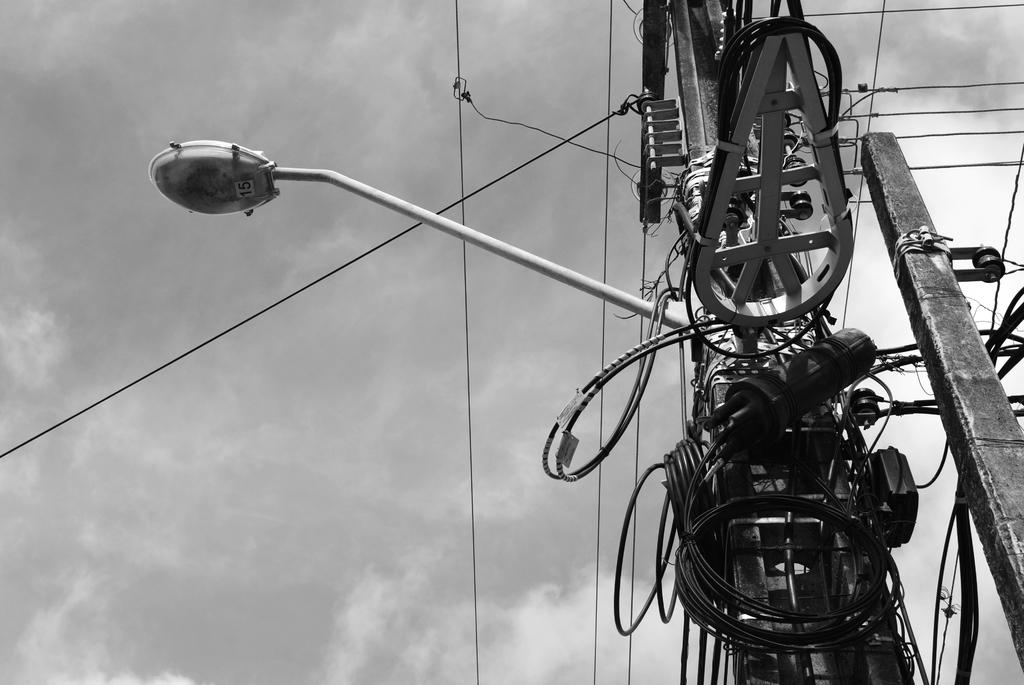What is the color scheme of the image? The image is black and white. What type of structure can be seen in the image? There is an electric pole and a power pole in the image. What is attached to the poles in the image? There is a street light and wires attached to the poles in the image. What can be seen in the background of the image? The sky is visible in the background of the image. What type of dress is the street light wearing in the image? Street lights do not wear dresses; they are inanimate objects. What sense is being stimulated by the wires in the image? The wires in the image are not designed to stimulate any sense; they are used for transmitting electricity. 